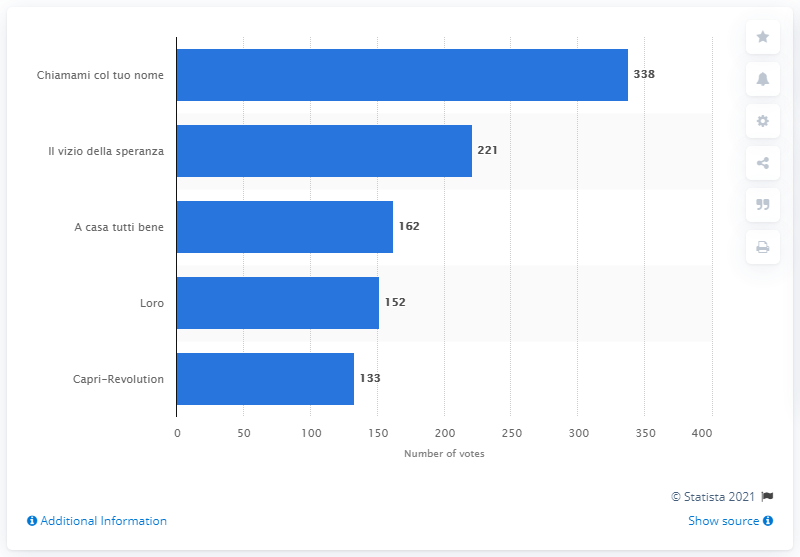Point out several critical features in this image. The song for the movie Chiamami col tuo nome received 338 votes. 